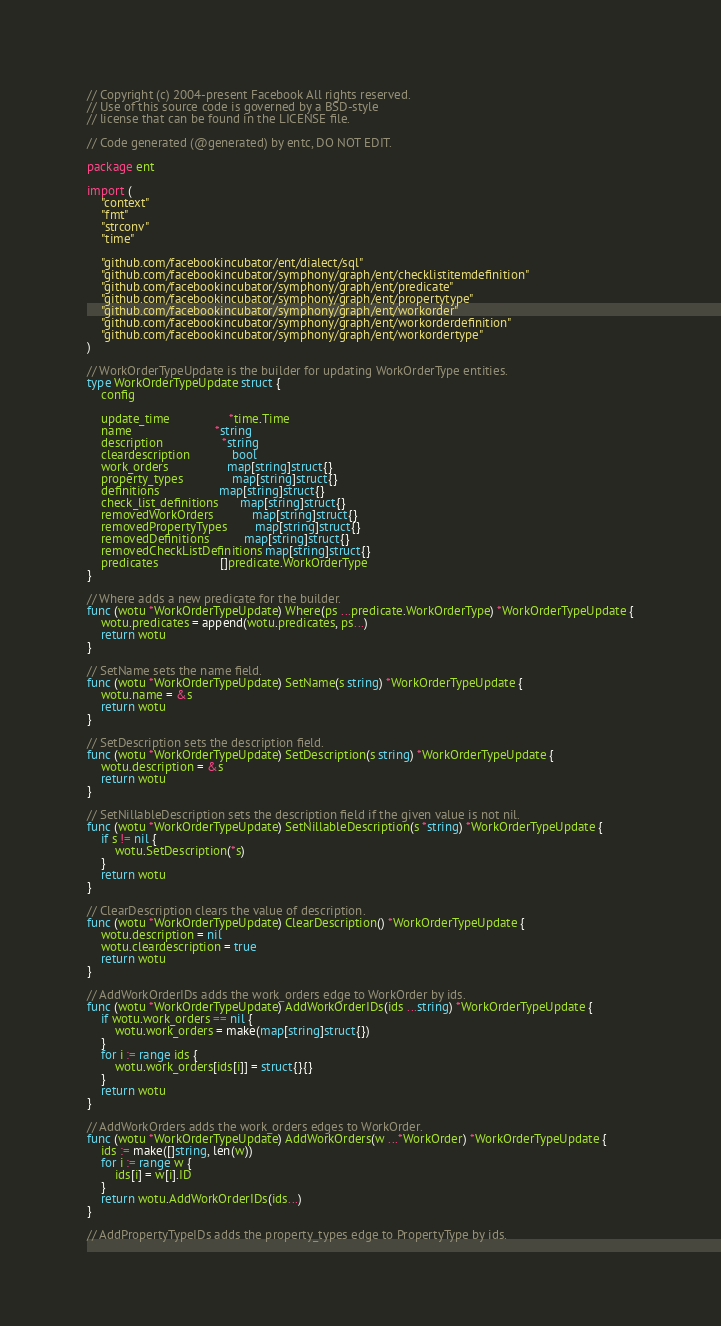<code> <loc_0><loc_0><loc_500><loc_500><_Go_>// Copyright (c) 2004-present Facebook All rights reserved.
// Use of this source code is governed by a BSD-style
// license that can be found in the LICENSE file.

// Code generated (@generated) by entc, DO NOT EDIT.

package ent

import (
	"context"
	"fmt"
	"strconv"
	"time"

	"github.com/facebookincubator/ent/dialect/sql"
	"github.com/facebookincubator/symphony/graph/ent/checklistitemdefinition"
	"github.com/facebookincubator/symphony/graph/ent/predicate"
	"github.com/facebookincubator/symphony/graph/ent/propertytype"
	"github.com/facebookincubator/symphony/graph/ent/workorder"
	"github.com/facebookincubator/symphony/graph/ent/workorderdefinition"
	"github.com/facebookincubator/symphony/graph/ent/workordertype"
)

// WorkOrderTypeUpdate is the builder for updating WorkOrderType entities.
type WorkOrderTypeUpdate struct {
	config

	update_time                 *time.Time
	name                        *string
	description                 *string
	cleardescription            bool
	work_orders                 map[string]struct{}
	property_types              map[string]struct{}
	definitions                 map[string]struct{}
	check_list_definitions      map[string]struct{}
	removedWorkOrders           map[string]struct{}
	removedPropertyTypes        map[string]struct{}
	removedDefinitions          map[string]struct{}
	removedCheckListDefinitions map[string]struct{}
	predicates                  []predicate.WorkOrderType
}

// Where adds a new predicate for the builder.
func (wotu *WorkOrderTypeUpdate) Where(ps ...predicate.WorkOrderType) *WorkOrderTypeUpdate {
	wotu.predicates = append(wotu.predicates, ps...)
	return wotu
}

// SetName sets the name field.
func (wotu *WorkOrderTypeUpdate) SetName(s string) *WorkOrderTypeUpdate {
	wotu.name = &s
	return wotu
}

// SetDescription sets the description field.
func (wotu *WorkOrderTypeUpdate) SetDescription(s string) *WorkOrderTypeUpdate {
	wotu.description = &s
	return wotu
}

// SetNillableDescription sets the description field if the given value is not nil.
func (wotu *WorkOrderTypeUpdate) SetNillableDescription(s *string) *WorkOrderTypeUpdate {
	if s != nil {
		wotu.SetDescription(*s)
	}
	return wotu
}

// ClearDescription clears the value of description.
func (wotu *WorkOrderTypeUpdate) ClearDescription() *WorkOrderTypeUpdate {
	wotu.description = nil
	wotu.cleardescription = true
	return wotu
}

// AddWorkOrderIDs adds the work_orders edge to WorkOrder by ids.
func (wotu *WorkOrderTypeUpdate) AddWorkOrderIDs(ids ...string) *WorkOrderTypeUpdate {
	if wotu.work_orders == nil {
		wotu.work_orders = make(map[string]struct{})
	}
	for i := range ids {
		wotu.work_orders[ids[i]] = struct{}{}
	}
	return wotu
}

// AddWorkOrders adds the work_orders edges to WorkOrder.
func (wotu *WorkOrderTypeUpdate) AddWorkOrders(w ...*WorkOrder) *WorkOrderTypeUpdate {
	ids := make([]string, len(w))
	for i := range w {
		ids[i] = w[i].ID
	}
	return wotu.AddWorkOrderIDs(ids...)
}

// AddPropertyTypeIDs adds the property_types edge to PropertyType by ids.</code> 